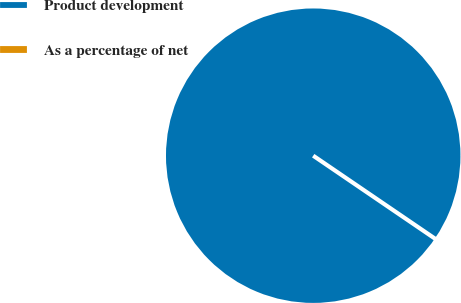Convert chart to OTSL. <chart><loc_0><loc_0><loc_500><loc_500><pie_chart><fcel>Product development<fcel>As a percentage of net<nl><fcel>100.0%<fcel>0.0%<nl></chart> 